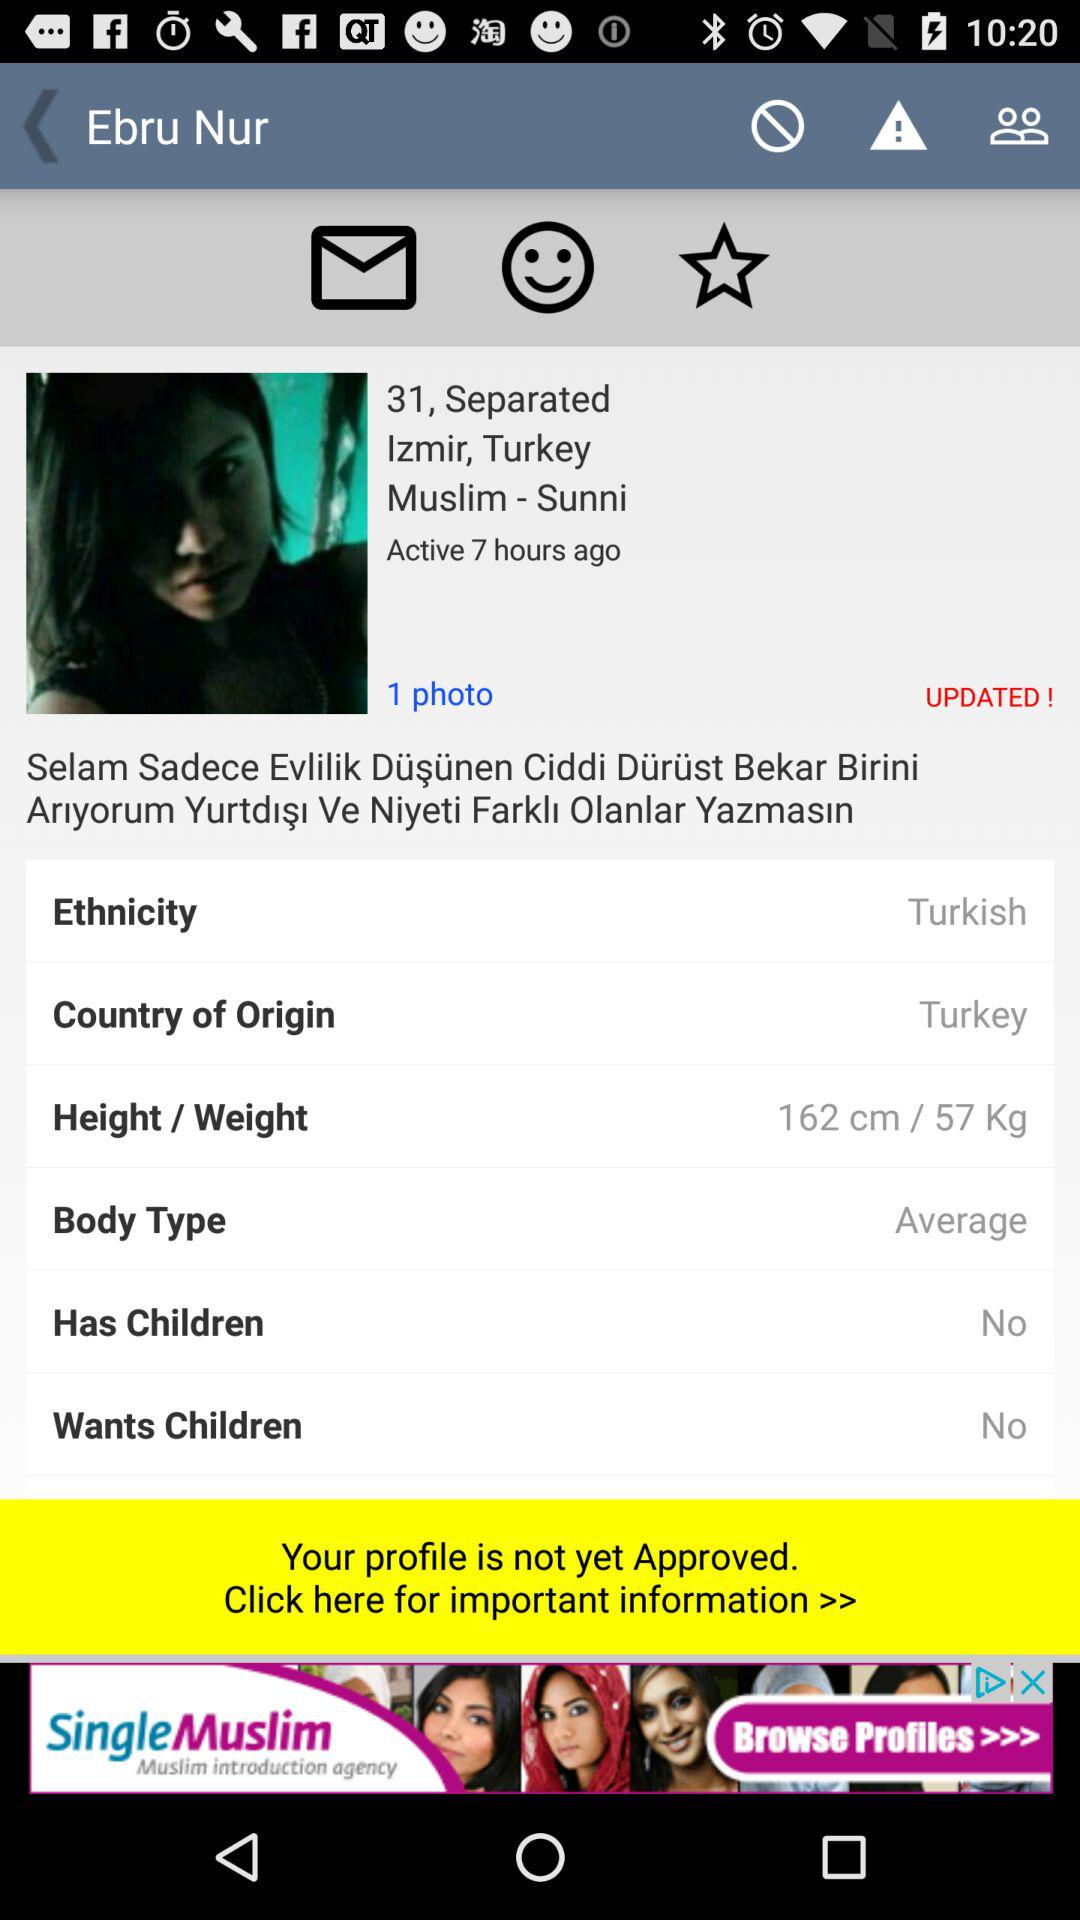What is the height? The height is 162 cm. 